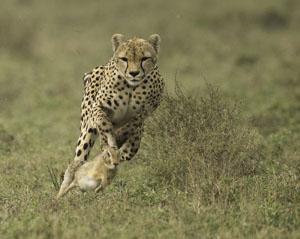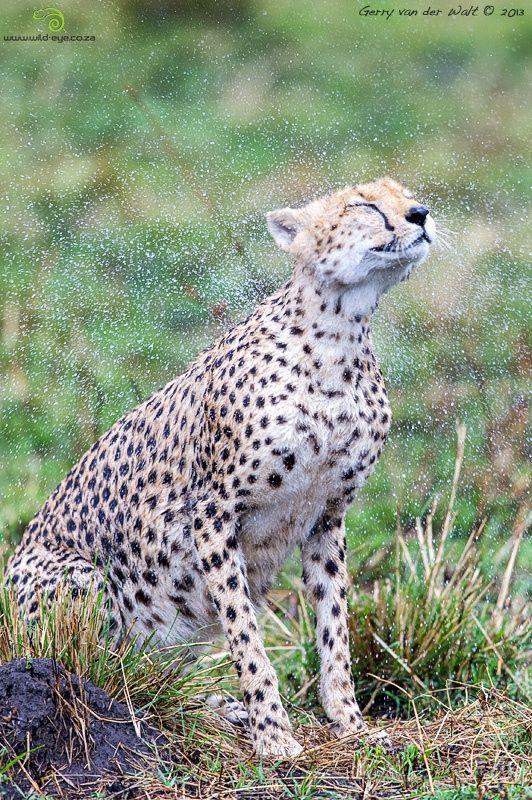The first image is the image on the left, the second image is the image on the right. For the images displayed, is the sentence "The leopard on the left is running after its prey." factually correct? Answer yes or no. Yes. The first image is the image on the left, the second image is the image on the right. Evaluate the accuracy of this statement regarding the images: "An image shows one spotted wild cat pursuing its prey.". Is it true? Answer yes or no. Yes. 